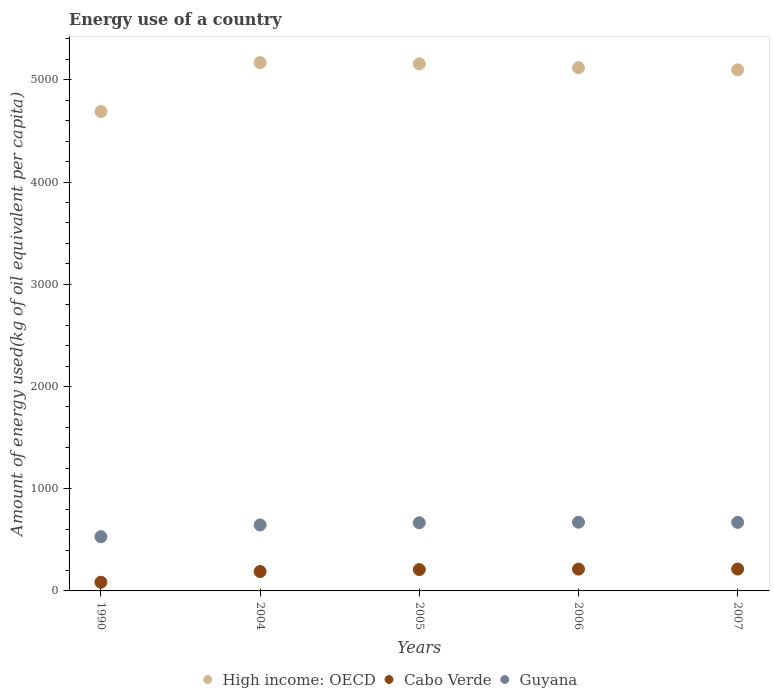What is the amount of energy used in in Guyana in 2005?
Your answer should be compact. 666.67. Across all years, what is the maximum amount of energy used in in Cabo Verde?
Make the answer very short. 214.01. Across all years, what is the minimum amount of energy used in in Guyana?
Give a very brief answer. 530.47. In which year was the amount of energy used in in Cabo Verde maximum?
Provide a succinct answer. 2007. In which year was the amount of energy used in in Cabo Verde minimum?
Provide a succinct answer. 1990. What is the total amount of energy used in in Guyana in the graph?
Offer a terse response. 3185.43. What is the difference between the amount of energy used in in High income: OECD in 2005 and that in 2006?
Your answer should be compact. 37.94. What is the difference between the amount of energy used in in Guyana in 2006 and the amount of energy used in in Cabo Verde in 2004?
Provide a short and direct response. 482.54. What is the average amount of energy used in in High income: OECD per year?
Provide a short and direct response. 5046.23. In the year 1990, what is the difference between the amount of energy used in in Guyana and amount of energy used in in High income: OECD?
Provide a succinct answer. -4158.94. What is the ratio of the amount of energy used in in Cabo Verde in 2005 to that in 2007?
Ensure brevity in your answer.  0.98. What is the difference between the highest and the second highest amount of energy used in in Guyana?
Keep it short and to the point. 1.74. What is the difference between the highest and the lowest amount of energy used in in High income: OECD?
Your answer should be very brief. 479.48. Is the sum of the amount of energy used in in Guyana in 2004 and 2007 greater than the maximum amount of energy used in in Cabo Verde across all years?
Keep it short and to the point. Yes. Is it the case that in every year, the sum of the amount of energy used in in Guyana and amount of energy used in in High income: OECD  is greater than the amount of energy used in in Cabo Verde?
Give a very brief answer. Yes. Does the amount of energy used in in Cabo Verde monotonically increase over the years?
Offer a terse response. Yes. Is the amount of energy used in in Guyana strictly greater than the amount of energy used in in High income: OECD over the years?
Offer a terse response. No. Is the amount of energy used in in Guyana strictly less than the amount of energy used in in High income: OECD over the years?
Offer a terse response. Yes. Does the graph contain any zero values?
Make the answer very short. No. Does the graph contain grids?
Ensure brevity in your answer.  No. Where does the legend appear in the graph?
Make the answer very short. Bottom center. How are the legend labels stacked?
Provide a short and direct response. Horizontal. What is the title of the graph?
Provide a short and direct response. Energy use of a country. What is the label or title of the X-axis?
Your response must be concise. Years. What is the label or title of the Y-axis?
Give a very brief answer. Amount of energy used(kg of oil equivalent per capita). What is the Amount of energy used(kg of oil equivalent per capita) of High income: OECD in 1990?
Provide a short and direct response. 4689.41. What is the Amount of energy used(kg of oil equivalent per capita) in Cabo Verde in 1990?
Ensure brevity in your answer.  85.12. What is the Amount of energy used(kg of oil equivalent per capita) in Guyana in 1990?
Your answer should be compact. 530.47. What is the Amount of energy used(kg of oil equivalent per capita) of High income: OECD in 2004?
Give a very brief answer. 5168.89. What is the Amount of energy used(kg of oil equivalent per capita) of Cabo Verde in 2004?
Give a very brief answer. 189.77. What is the Amount of energy used(kg of oil equivalent per capita) of Guyana in 2004?
Provide a short and direct response. 645.41. What is the Amount of energy used(kg of oil equivalent per capita) of High income: OECD in 2005?
Make the answer very short. 5156.46. What is the Amount of energy used(kg of oil equivalent per capita) in Cabo Verde in 2005?
Provide a short and direct response. 208.76. What is the Amount of energy used(kg of oil equivalent per capita) in Guyana in 2005?
Offer a very short reply. 666.67. What is the Amount of energy used(kg of oil equivalent per capita) of High income: OECD in 2006?
Your response must be concise. 5118.52. What is the Amount of energy used(kg of oil equivalent per capita) in Cabo Verde in 2006?
Provide a short and direct response. 213.27. What is the Amount of energy used(kg of oil equivalent per capita) of Guyana in 2006?
Make the answer very short. 672.31. What is the Amount of energy used(kg of oil equivalent per capita) in High income: OECD in 2007?
Keep it short and to the point. 5097.86. What is the Amount of energy used(kg of oil equivalent per capita) of Cabo Verde in 2007?
Ensure brevity in your answer.  214.01. What is the Amount of energy used(kg of oil equivalent per capita) in Guyana in 2007?
Make the answer very short. 670.57. Across all years, what is the maximum Amount of energy used(kg of oil equivalent per capita) of High income: OECD?
Offer a terse response. 5168.89. Across all years, what is the maximum Amount of energy used(kg of oil equivalent per capita) of Cabo Verde?
Provide a short and direct response. 214.01. Across all years, what is the maximum Amount of energy used(kg of oil equivalent per capita) in Guyana?
Provide a short and direct response. 672.31. Across all years, what is the minimum Amount of energy used(kg of oil equivalent per capita) in High income: OECD?
Ensure brevity in your answer.  4689.41. Across all years, what is the minimum Amount of energy used(kg of oil equivalent per capita) of Cabo Verde?
Ensure brevity in your answer.  85.12. Across all years, what is the minimum Amount of energy used(kg of oil equivalent per capita) in Guyana?
Your answer should be compact. 530.47. What is the total Amount of energy used(kg of oil equivalent per capita) of High income: OECD in the graph?
Offer a very short reply. 2.52e+04. What is the total Amount of energy used(kg of oil equivalent per capita) of Cabo Verde in the graph?
Offer a very short reply. 910.93. What is the total Amount of energy used(kg of oil equivalent per capita) of Guyana in the graph?
Keep it short and to the point. 3185.43. What is the difference between the Amount of energy used(kg of oil equivalent per capita) of High income: OECD in 1990 and that in 2004?
Your answer should be very brief. -479.48. What is the difference between the Amount of energy used(kg of oil equivalent per capita) of Cabo Verde in 1990 and that in 2004?
Keep it short and to the point. -104.66. What is the difference between the Amount of energy used(kg of oil equivalent per capita) in Guyana in 1990 and that in 2004?
Ensure brevity in your answer.  -114.94. What is the difference between the Amount of energy used(kg of oil equivalent per capita) of High income: OECD in 1990 and that in 2005?
Provide a succinct answer. -467.04. What is the difference between the Amount of energy used(kg of oil equivalent per capita) in Cabo Verde in 1990 and that in 2005?
Offer a very short reply. -123.65. What is the difference between the Amount of energy used(kg of oil equivalent per capita) of Guyana in 1990 and that in 2005?
Your answer should be compact. -136.2. What is the difference between the Amount of energy used(kg of oil equivalent per capita) of High income: OECD in 1990 and that in 2006?
Give a very brief answer. -429.11. What is the difference between the Amount of energy used(kg of oil equivalent per capita) of Cabo Verde in 1990 and that in 2006?
Ensure brevity in your answer.  -128.16. What is the difference between the Amount of energy used(kg of oil equivalent per capita) of Guyana in 1990 and that in 2006?
Ensure brevity in your answer.  -141.84. What is the difference between the Amount of energy used(kg of oil equivalent per capita) in High income: OECD in 1990 and that in 2007?
Keep it short and to the point. -408.45. What is the difference between the Amount of energy used(kg of oil equivalent per capita) of Cabo Verde in 1990 and that in 2007?
Keep it short and to the point. -128.9. What is the difference between the Amount of energy used(kg of oil equivalent per capita) in Guyana in 1990 and that in 2007?
Your answer should be very brief. -140.1. What is the difference between the Amount of energy used(kg of oil equivalent per capita) in High income: OECD in 2004 and that in 2005?
Your answer should be very brief. 12.43. What is the difference between the Amount of energy used(kg of oil equivalent per capita) of Cabo Verde in 2004 and that in 2005?
Offer a terse response. -18.99. What is the difference between the Amount of energy used(kg of oil equivalent per capita) of Guyana in 2004 and that in 2005?
Offer a terse response. -21.26. What is the difference between the Amount of energy used(kg of oil equivalent per capita) of High income: OECD in 2004 and that in 2006?
Keep it short and to the point. 50.37. What is the difference between the Amount of energy used(kg of oil equivalent per capita) in Cabo Verde in 2004 and that in 2006?
Offer a terse response. -23.5. What is the difference between the Amount of energy used(kg of oil equivalent per capita) in Guyana in 2004 and that in 2006?
Give a very brief answer. -26.9. What is the difference between the Amount of energy used(kg of oil equivalent per capita) in High income: OECD in 2004 and that in 2007?
Offer a very short reply. 71.03. What is the difference between the Amount of energy used(kg of oil equivalent per capita) in Cabo Verde in 2004 and that in 2007?
Your answer should be compact. -24.24. What is the difference between the Amount of energy used(kg of oil equivalent per capita) of Guyana in 2004 and that in 2007?
Provide a short and direct response. -25.16. What is the difference between the Amount of energy used(kg of oil equivalent per capita) in High income: OECD in 2005 and that in 2006?
Give a very brief answer. 37.94. What is the difference between the Amount of energy used(kg of oil equivalent per capita) of Cabo Verde in 2005 and that in 2006?
Ensure brevity in your answer.  -4.51. What is the difference between the Amount of energy used(kg of oil equivalent per capita) in Guyana in 2005 and that in 2006?
Make the answer very short. -5.64. What is the difference between the Amount of energy used(kg of oil equivalent per capita) in High income: OECD in 2005 and that in 2007?
Keep it short and to the point. 58.6. What is the difference between the Amount of energy used(kg of oil equivalent per capita) in Cabo Verde in 2005 and that in 2007?
Give a very brief answer. -5.25. What is the difference between the Amount of energy used(kg of oil equivalent per capita) of Guyana in 2005 and that in 2007?
Provide a succinct answer. -3.9. What is the difference between the Amount of energy used(kg of oil equivalent per capita) of High income: OECD in 2006 and that in 2007?
Make the answer very short. 20.66. What is the difference between the Amount of energy used(kg of oil equivalent per capita) of Cabo Verde in 2006 and that in 2007?
Offer a terse response. -0.74. What is the difference between the Amount of energy used(kg of oil equivalent per capita) of Guyana in 2006 and that in 2007?
Provide a short and direct response. 1.74. What is the difference between the Amount of energy used(kg of oil equivalent per capita) in High income: OECD in 1990 and the Amount of energy used(kg of oil equivalent per capita) in Cabo Verde in 2004?
Your answer should be compact. 4499.64. What is the difference between the Amount of energy used(kg of oil equivalent per capita) in High income: OECD in 1990 and the Amount of energy used(kg of oil equivalent per capita) in Guyana in 2004?
Offer a terse response. 4044. What is the difference between the Amount of energy used(kg of oil equivalent per capita) in Cabo Verde in 1990 and the Amount of energy used(kg of oil equivalent per capita) in Guyana in 2004?
Your answer should be very brief. -560.3. What is the difference between the Amount of energy used(kg of oil equivalent per capita) in High income: OECD in 1990 and the Amount of energy used(kg of oil equivalent per capita) in Cabo Verde in 2005?
Give a very brief answer. 4480.65. What is the difference between the Amount of energy used(kg of oil equivalent per capita) in High income: OECD in 1990 and the Amount of energy used(kg of oil equivalent per capita) in Guyana in 2005?
Your answer should be compact. 4022.74. What is the difference between the Amount of energy used(kg of oil equivalent per capita) of Cabo Verde in 1990 and the Amount of energy used(kg of oil equivalent per capita) of Guyana in 2005?
Your answer should be compact. -581.56. What is the difference between the Amount of energy used(kg of oil equivalent per capita) of High income: OECD in 1990 and the Amount of energy used(kg of oil equivalent per capita) of Cabo Verde in 2006?
Your answer should be very brief. 4476.14. What is the difference between the Amount of energy used(kg of oil equivalent per capita) in High income: OECD in 1990 and the Amount of energy used(kg of oil equivalent per capita) in Guyana in 2006?
Give a very brief answer. 4017.1. What is the difference between the Amount of energy used(kg of oil equivalent per capita) in Cabo Verde in 1990 and the Amount of energy used(kg of oil equivalent per capita) in Guyana in 2006?
Provide a succinct answer. -587.19. What is the difference between the Amount of energy used(kg of oil equivalent per capita) of High income: OECD in 1990 and the Amount of energy used(kg of oil equivalent per capita) of Cabo Verde in 2007?
Provide a short and direct response. 4475.4. What is the difference between the Amount of energy used(kg of oil equivalent per capita) of High income: OECD in 1990 and the Amount of energy used(kg of oil equivalent per capita) of Guyana in 2007?
Your response must be concise. 4018.84. What is the difference between the Amount of energy used(kg of oil equivalent per capita) of Cabo Verde in 1990 and the Amount of energy used(kg of oil equivalent per capita) of Guyana in 2007?
Give a very brief answer. -585.45. What is the difference between the Amount of energy used(kg of oil equivalent per capita) in High income: OECD in 2004 and the Amount of energy used(kg of oil equivalent per capita) in Cabo Verde in 2005?
Your response must be concise. 4960.13. What is the difference between the Amount of energy used(kg of oil equivalent per capita) in High income: OECD in 2004 and the Amount of energy used(kg of oil equivalent per capita) in Guyana in 2005?
Keep it short and to the point. 4502.22. What is the difference between the Amount of energy used(kg of oil equivalent per capita) in Cabo Verde in 2004 and the Amount of energy used(kg of oil equivalent per capita) in Guyana in 2005?
Your response must be concise. -476.9. What is the difference between the Amount of energy used(kg of oil equivalent per capita) of High income: OECD in 2004 and the Amount of energy used(kg of oil equivalent per capita) of Cabo Verde in 2006?
Offer a very short reply. 4955.62. What is the difference between the Amount of energy used(kg of oil equivalent per capita) in High income: OECD in 2004 and the Amount of energy used(kg of oil equivalent per capita) in Guyana in 2006?
Give a very brief answer. 4496.58. What is the difference between the Amount of energy used(kg of oil equivalent per capita) in Cabo Verde in 2004 and the Amount of energy used(kg of oil equivalent per capita) in Guyana in 2006?
Offer a very short reply. -482.54. What is the difference between the Amount of energy used(kg of oil equivalent per capita) of High income: OECD in 2004 and the Amount of energy used(kg of oil equivalent per capita) of Cabo Verde in 2007?
Give a very brief answer. 4954.88. What is the difference between the Amount of energy used(kg of oil equivalent per capita) of High income: OECD in 2004 and the Amount of energy used(kg of oil equivalent per capita) of Guyana in 2007?
Your answer should be compact. 4498.32. What is the difference between the Amount of energy used(kg of oil equivalent per capita) in Cabo Verde in 2004 and the Amount of energy used(kg of oil equivalent per capita) in Guyana in 2007?
Offer a terse response. -480.8. What is the difference between the Amount of energy used(kg of oil equivalent per capita) of High income: OECD in 2005 and the Amount of energy used(kg of oil equivalent per capita) of Cabo Verde in 2006?
Provide a short and direct response. 4943.18. What is the difference between the Amount of energy used(kg of oil equivalent per capita) of High income: OECD in 2005 and the Amount of energy used(kg of oil equivalent per capita) of Guyana in 2006?
Ensure brevity in your answer.  4484.15. What is the difference between the Amount of energy used(kg of oil equivalent per capita) of Cabo Verde in 2005 and the Amount of energy used(kg of oil equivalent per capita) of Guyana in 2006?
Make the answer very short. -463.55. What is the difference between the Amount of energy used(kg of oil equivalent per capita) of High income: OECD in 2005 and the Amount of energy used(kg of oil equivalent per capita) of Cabo Verde in 2007?
Your answer should be very brief. 4942.44. What is the difference between the Amount of energy used(kg of oil equivalent per capita) of High income: OECD in 2005 and the Amount of energy used(kg of oil equivalent per capita) of Guyana in 2007?
Your answer should be very brief. 4485.89. What is the difference between the Amount of energy used(kg of oil equivalent per capita) in Cabo Verde in 2005 and the Amount of energy used(kg of oil equivalent per capita) in Guyana in 2007?
Make the answer very short. -461.8. What is the difference between the Amount of energy used(kg of oil equivalent per capita) of High income: OECD in 2006 and the Amount of energy used(kg of oil equivalent per capita) of Cabo Verde in 2007?
Provide a short and direct response. 4904.51. What is the difference between the Amount of energy used(kg of oil equivalent per capita) in High income: OECD in 2006 and the Amount of energy used(kg of oil equivalent per capita) in Guyana in 2007?
Give a very brief answer. 4447.95. What is the difference between the Amount of energy used(kg of oil equivalent per capita) in Cabo Verde in 2006 and the Amount of energy used(kg of oil equivalent per capita) in Guyana in 2007?
Your response must be concise. -457.3. What is the average Amount of energy used(kg of oil equivalent per capita) of High income: OECD per year?
Provide a short and direct response. 5046.23. What is the average Amount of energy used(kg of oil equivalent per capita) in Cabo Verde per year?
Provide a short and direct response. 182.19. What is the average Amount of energy used(kg of oil equivalent per capita) in Guyana per year?
Your answer should be compact. 637.09. In the year 1990, what is the difference between the Amount of energy used(kg of oil equivalent per capita) in High income: OECD and Amount of energy used(kg of oil equivalent per capita) in Cabo Verde?
Make the answer very short. 4604.3. In the year 1990, what is the difference between the Amount of energy used(kg of oil equivalent per capita) of High income: OECD and Amount of energy used(kg of oil equivalent per capita) of Guyana?
Keep it short and to the point. 4158.94. In the year 1990, what is the difference between the Amount of energy used(kg of oil equivalent per capita) in Cabo Verde and Amount of energy used(kg of oil equivalent per capita) in Guyana?
Ensure brevity in your answer.  -445.35. In the year 2004, what is the difference between the Amount of energy used(kg of oil equivalent per capita) in High income: OECD and Amount of energy used(kg of oil equivalent per capita) in Cabo Verde?
Provide a short and direct response. 4979.12. In the year 2004, what is the difference between the Amount of energy used(kg of oil equivalent per capita) in High income: OECD and Amount of energy used(kg of oil equivalent per capita) in Guyana?
Your answer should be compact. 4523.48. In the year 2004, what is the difference between the Amount of energy used(kg of oil equivalent per capita) of Cabo Verde and Amount of energy used(kg of oil equivalent per capita) of Guyana?
Make the answer very short. -455.64. In the year 2005, what is the difference between the Amount of energy used(kg of oil equivalent per capita) in High income: OECD and Amount of energy used(kg of oil equivalent per capita) in Cabo Verde?
Give a very brief answer. 4947.69. In the year 2005, what is the difference between the Amount of energy used(kg of oil equivalent per capita) in High income: OECD and Amount of energy used(kg of oil equivalent per capita) in Guyana?
Offer a terse response. 4489.78. In the year 2005, what is the difference between the Amount of energy used(kg of oil equivalent per capita) of Cabo Verde and Amount of energy used(kg of oil equivalent per capita) of Guyana?
Ensure brevity in your answer.  -457.91. In the year 2006, what is the difference between the Amount of energy used(kg of oil equivalent per capita) of High income: OECD and Amount of energy used(kg of oil equivalent per capita) of Cabo Verde?
Provide a succinct answer. 4905.25. In the year 2006, what is the difference between the Amount of energy used(kg of oil equivalent per capita) of High income: OECD and Amount of energy used(kg of oil equivalent per capita) of Guyana?
Make the answer very short. 4446.21. In the year 2006, what is the difference between the Amount of energy used(kg of oil equivalent per capita) in Cabo Verde and Amount of energy used(kg of oil equivalent per capita) in Guyana?
Give a very brief answer. -459.04. In the year 2007, what is the difference between the Amount of energy used(kg of oil equivalent per capita) of High income: OECD and Amount of energy used(kg of oil equivalent per capita) of Cabo Verde?
Your response must be concise. 4883.85. In the year 2007, what is the difference between the Amount of energy used(kg of oil equivalent per capita) of High income: OECD and Amount of energy used(kg of oil equivalent per capita) of Guyana?
Provide a succinct answer. 4427.29. In the year 2007, what is the difference between the Amount of energy used(kg of oil equivalent per capita) in Cabo Verde and Amount of energy used(kg of oil equivalent per capita) in Guyana?
Offer a very short reply. -456.55. What is the ratio of the Amount of energy used(kg of oil equivalent per capita) of High income: OECD in 1990 to that in 2004?
Provide a short and direct response. 0.91. What is the ratio of the Amount of energy used(kg of oil equivalent per capita) in Cabo Verde in 1990 to that in 2004?
Offer a very short reply. 0.45. What is the ratio of the Amount of energy used(kg of oil equivalent per capita) of Guyana in 1990 to that in 2004?
Provide a short and direct response. 0.82. What is the ratio of the Amount of energy used(kg of oil equivalent per capita) of High income: OECD in 1990 to that in 2005?
Provide a succinct answer. 0.91. What is the ratio of the Amount of energy used(kg of oil equivalent per capita) of Cabo Verde in 1990 to that in 2005?
Provide a succinct answer. 0.41. What is the ratio of the Amount of energy used(kg of oil equivalent per capita) in Guyana in 1990 to that in 2005?
Ensure brevity in your answer.  0.8. What is the ratio of the Amount of energy used(kg of oil equivalent per capita) in High income: OECD in 1990 to that in 2006?
Offer a very short reply. 0.92. What is the ratio of the Amount of energy used(kg of oil equivalent per capita) of Cabo Verde in 1990 to that in 2006?
Your answer should be compact. 0.4. What is the ratio of the Amount of energy used(kg of oil equivalent per capita) of Guyana in 1990 to that in 2006?
Your answer should be compact. 0.79. What is the ratio of the Amount of energy used(kg of oil equivalent per capita) of High income: OECD in 1990 to that in 2007?
Offer a very short reply. 0.92. What is the ratio of the Amount of energy used(kg of oil equivalent per capita) of Cabo Verde in 1990 to that in 2007?
Make the answer very short. 0.4. What is the ratio of the Amount of energy used(kg of oil equivalent per capita) of Guyana in 1990 to that in 2007?
Provide a short and direct response. 0.79. What is the ratio of the Amount of energy used(kg of oil equivalent per capita) of High income: OECD in 2004 to that in 2005?
Provide a succinct answer. 1. What is the ratio of the Amount of energy used(kg of oil equivalent per capita) of Cabo Verde in 2004 to that in 2005?
Provide a succinct answer. 0.91. What is the ratio of the Amount of energy used(kg of oil equivalent per capita) in Guyana in 2004 to that in 2005?
Keep it short and to the point. 0.97. What is the ratio of the Amount of energy used(kg of oil equivalent per capita) of High income: OECD in 2004 to that in 2006?
Provide a succinct answer. 1.01. What is the ratio of the Amount of energy used(kg of oil equivalent per capita) of Cabo Verde in 2004 to that in 2006?
Offer a terse response. 0.89. What is the ratio of the Amount of energy used(kg of oil equivalent per capita) in Guyana in 2004 to that in 2006?
Offer a very short reply. 0.96. What is the ratio of the Amount of energy used(kg of oil equivalent per capita) in High income: OECD in 2004 to that in 2007?
Provide a short and direct response. 1.01. What is the ratio of the Amount of energy used(kg of oil equivalent per capita) of Cabo Verde in 2004 to that in 2007?
Offer a terse response. 0.89. What is the ratio of the Amount of energy used(kg of oil equivalent per capita) in Guyana in 2004 to that in 2007?
Give a very brief answer. 0.96. What is the ratio of the Amount of energy used(kg of oil equivalent per capita) in High income: OECD in 2005 to that in 2006?
Offer a terse response. 1.01. What is the ratio of the Amount of energy used(kg of oil equivalent per capita) in Cabo Verde in 2005 to that in 2006?
Provide a short and direct response. 0.98. What is the ratio of the Amount of energy used(kg of oil equivalent per capita) of High income: OECD in 2005 to that in 2007?
Your answer should be very brief. 1.01. What is the ratio of the Amount of energy used(kg of oil equivalent per capita) of Cabo Verde in 2005 to that in 2007?
Your answer should be very brief. 0.98. What is the ratio of the Amount of energy used(kg of oil equivalent per capita) of Guyana in 2005 to that in 2007?
Keep it short and to the point. 0.99. What is the difference between the highest and the second highest Amount of energy used(kg of oil equivalent per capita) of High income: OECD?
Your answer should be compact. 12.43. What is the difference between the highest and the second highest Amount of energy used(kg of oil equivalent per capita) in Cabo Verde?
Ensure brevity in your answer.  0.74. What is the difference between the highest and the second highest Amount of energy used(kg of oil equivalent per capita) of Guyana?
Give a very brief answer. 1.74. What is the difference between the highest and the lowest Amount of energy used(kg of oil equivalent per capita) of High income: OECD?
Provide a succinct answer. 479.48. What is the difference between the highest and the lowest Amount of energy used(kg of oil equivalent per capita) of Cabo Verde?
Provide a succinct answer. 128.9. What is the difference between the highest and the lowest Amount of energy used(kg of oil equivalent per capita) of Guyana?
Keep it short and to the point. 141.84. 